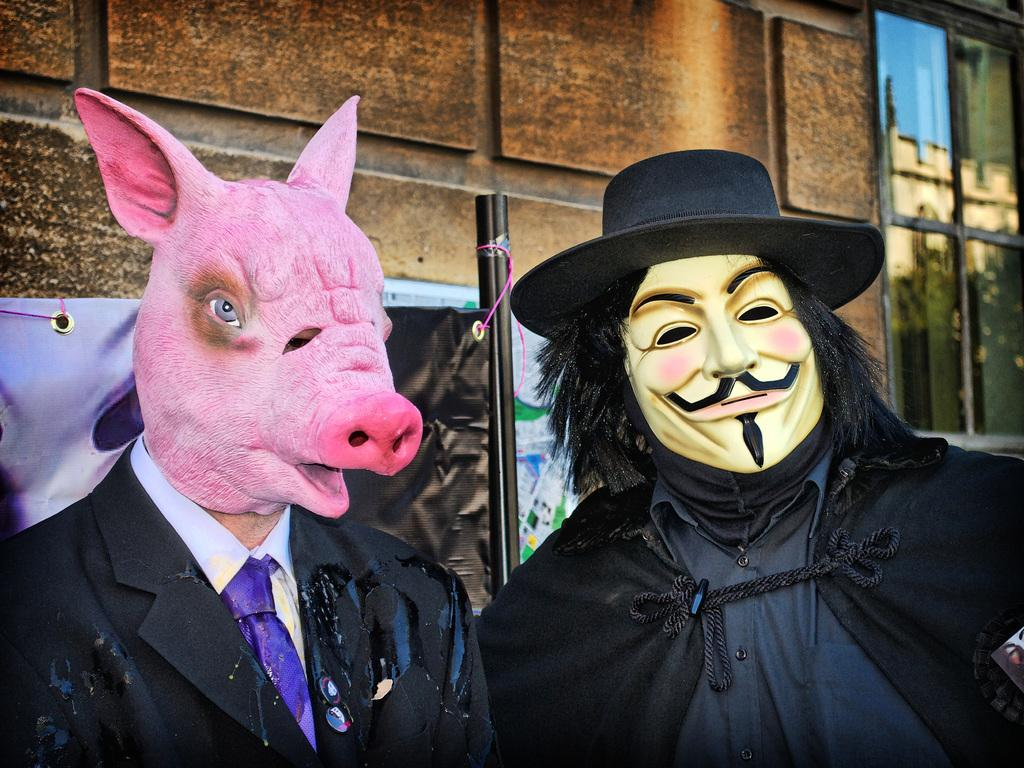How many people are in the image? There are two persons in the image. What are the persons wearing on their faces? The persons are wearing masks. What can be seen in the background of the image? There is a banner, a building, and a glass window in the background of the image. In which direction are the persons jumping in the image? There is no jumping in the image; the persons are standing. 